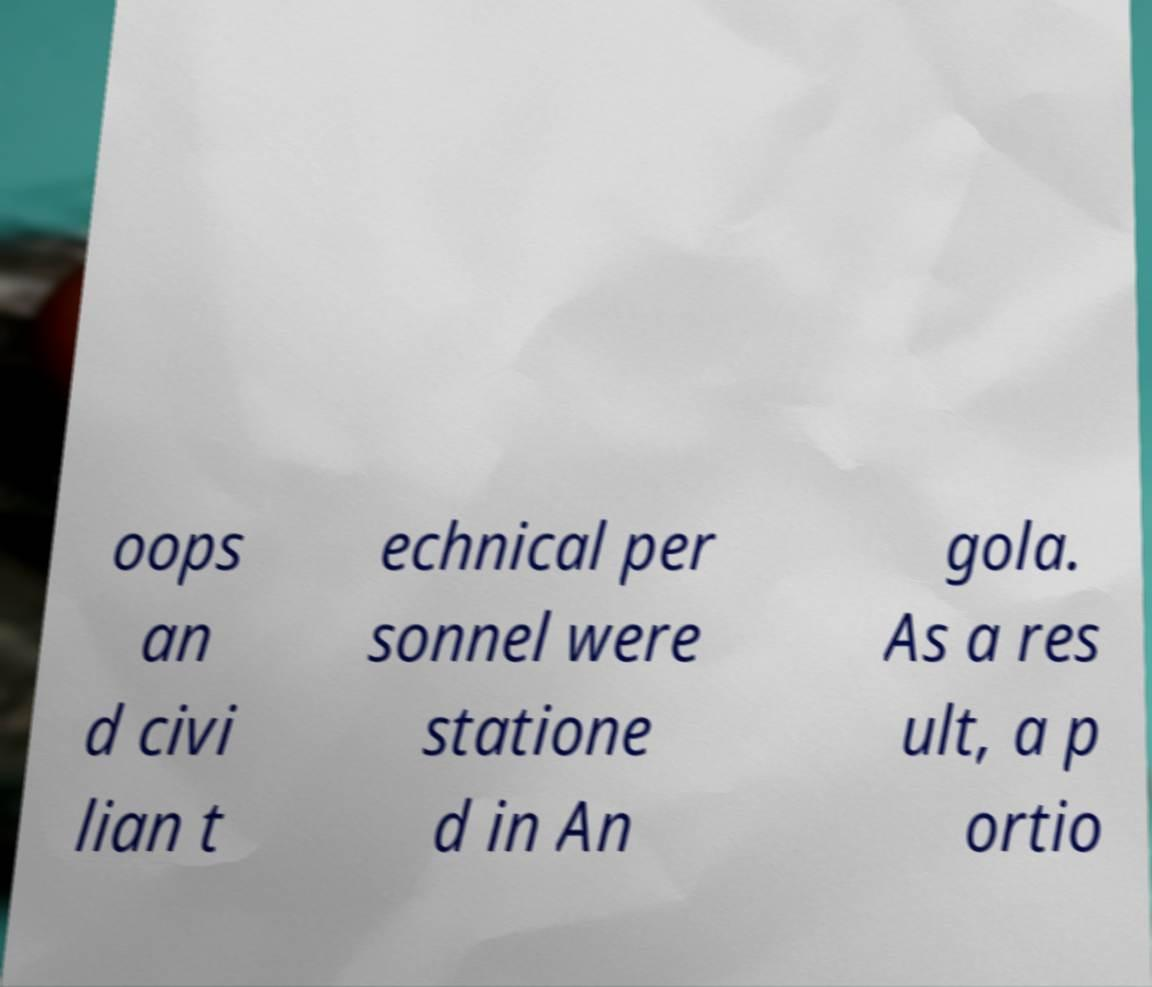What messages or text are displayed in this image? I need them in a readable, typed format. oops an d civi lian t echnical per sonnel were statione d in An gola. As a res ult, a p ortio 